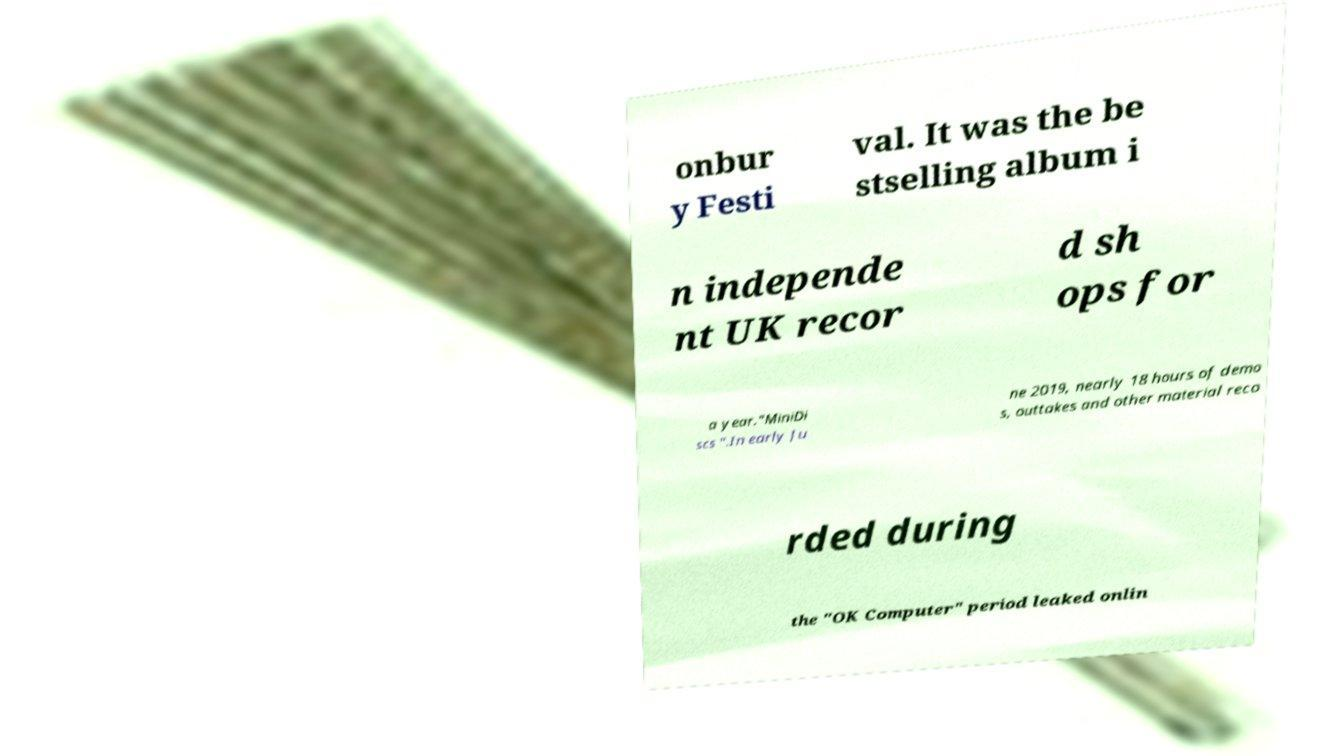For documentation purposes, I need the text within this image transcribed. Could you provide that? onbur y Festi val. It was the be stselling album i n independe nt UK recor d sh ops for a year."MiniDi scs ".In early Ju ne 2019, nearly 18 hours of demo s, outtakes and other material reco rded during the "OK Computer" period leaked onlin 